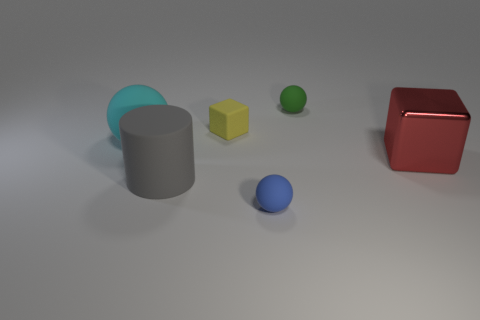Is there anything else that is made of the same material as the red block?
Your answer should be compact. No. How many objects are either tiny balls behind the large shiny thing or big things in front of the red object?
Give a very brief answer. 2. Are there fewer matte blocks left of the gray matte cylinder than large blue metal cylinders?
Offer a terse response. No. Is there another thing that has the same size as the gray object?
Your answer should be compact. Yes. The big rubber ball has what color?
Keep it short and to the point. Cyan. Do the shiny cube and the gray cylinder have the same size?
Provide a succinct answer. Yes. How many objects are green metallic things or large metal things?
Your answer should be very brief. 1. Is the number of big matte things that are in front of the big red cube the same as the number of tiny green objects?
Offer a terse response. Yes. There is a block to the right of the tiny ball that is behind the yellow cube; are there any tiny yellow matte blocks right of it?
Offer a very short reply. No. The cylinder that is the same material as the tiny cube is what color?
Your response must be concise. Gray. 